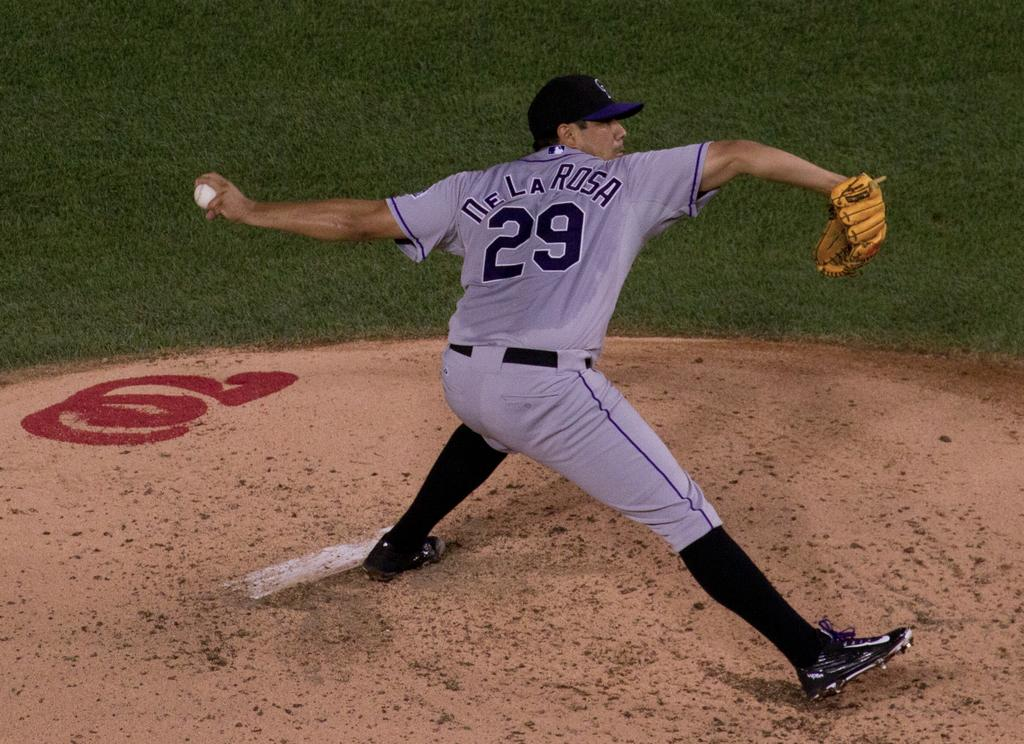Provide a one-sentence caption for the provided image. Player number 29, De La Rosa is shown right as he is pitching the ball out on the field. 